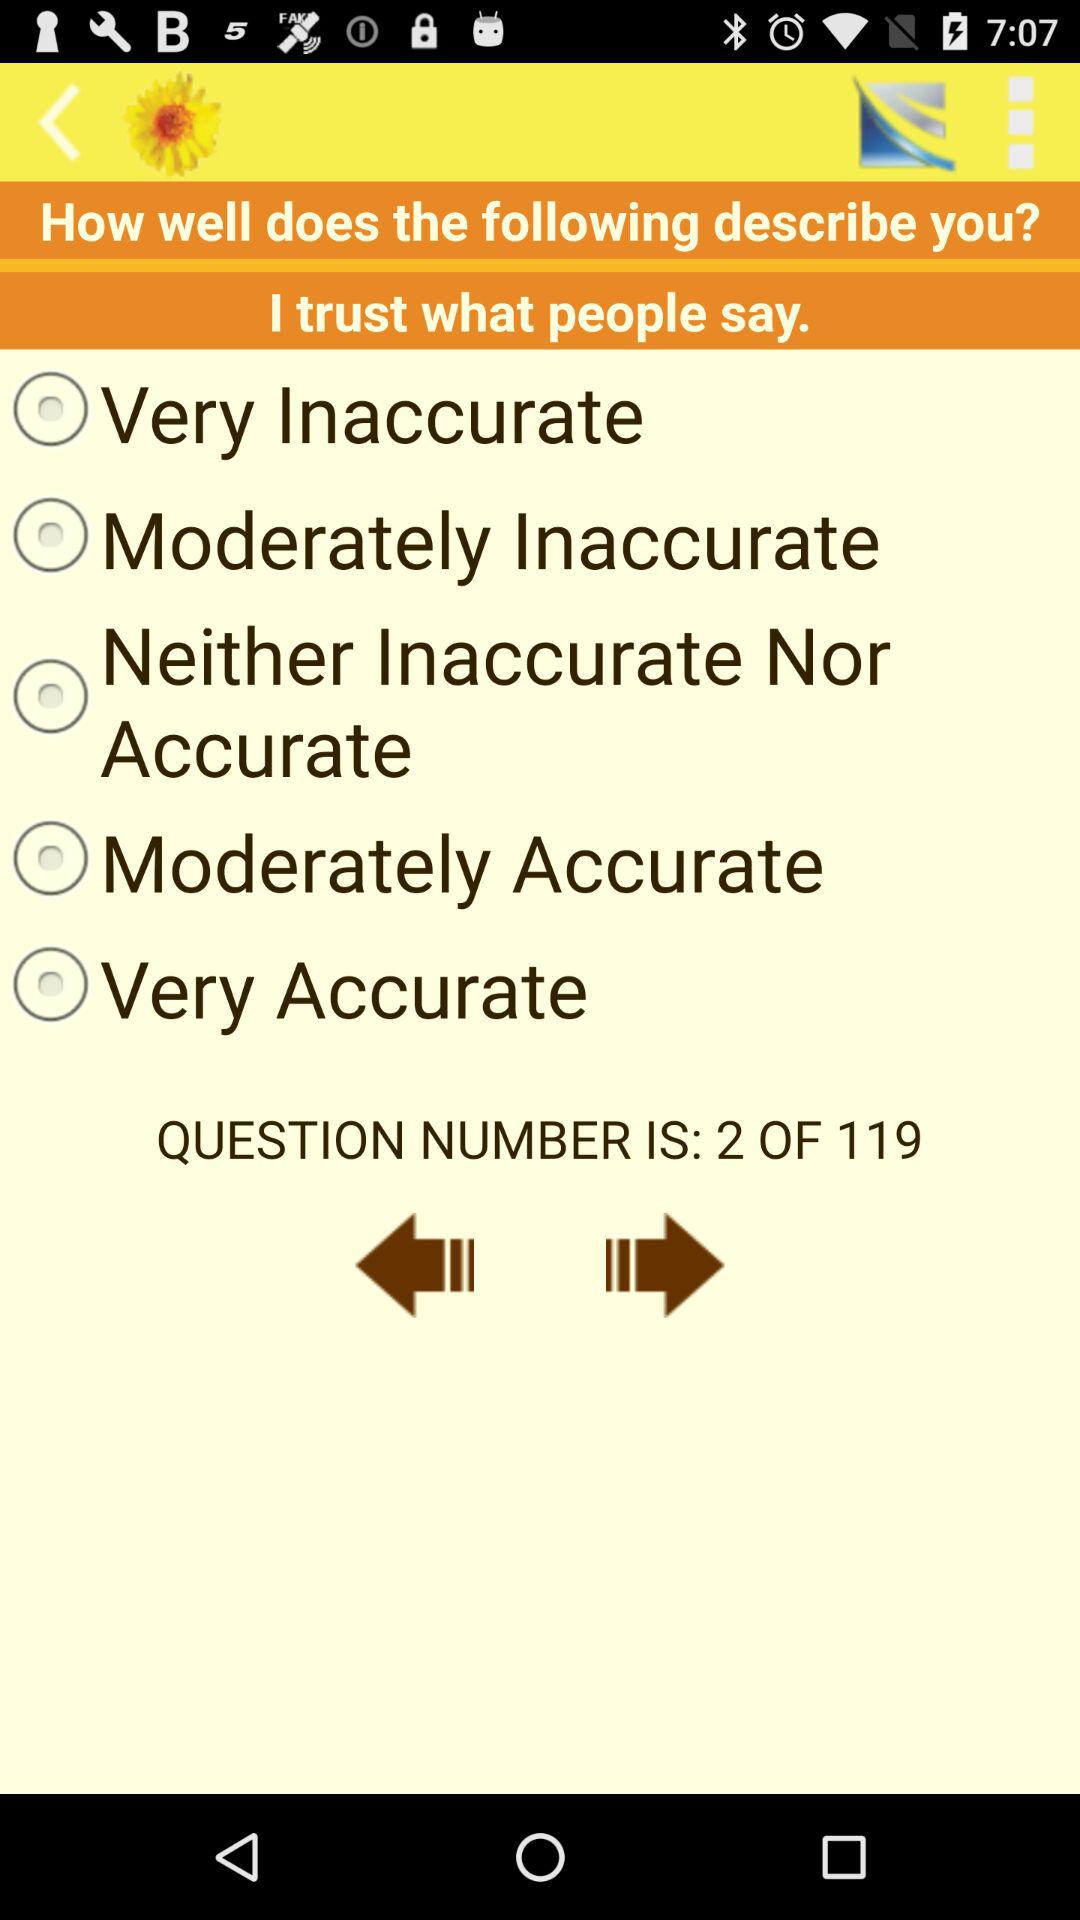What is the question? The question is, "How well does the following describe you?". 